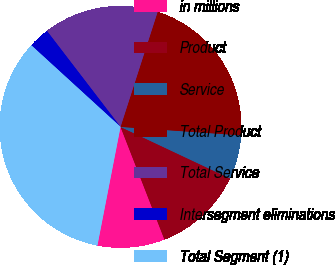<chart> <loc_0><loc_0><loc_500><loc_500><pie_chart><fcel>in millions<fcel>Product<fcel>Service<fcel>Total Product<fcel>Total Service<fcel>Intersegment eliminations<fcel>Total Segment (1)<nl><fcel>8.98%<fcel>12.08%<fcel>5.89%<fcel>21.15%<fcel>15.38%<fcel>2.8%<fcel>33.73%<nl></chart> 